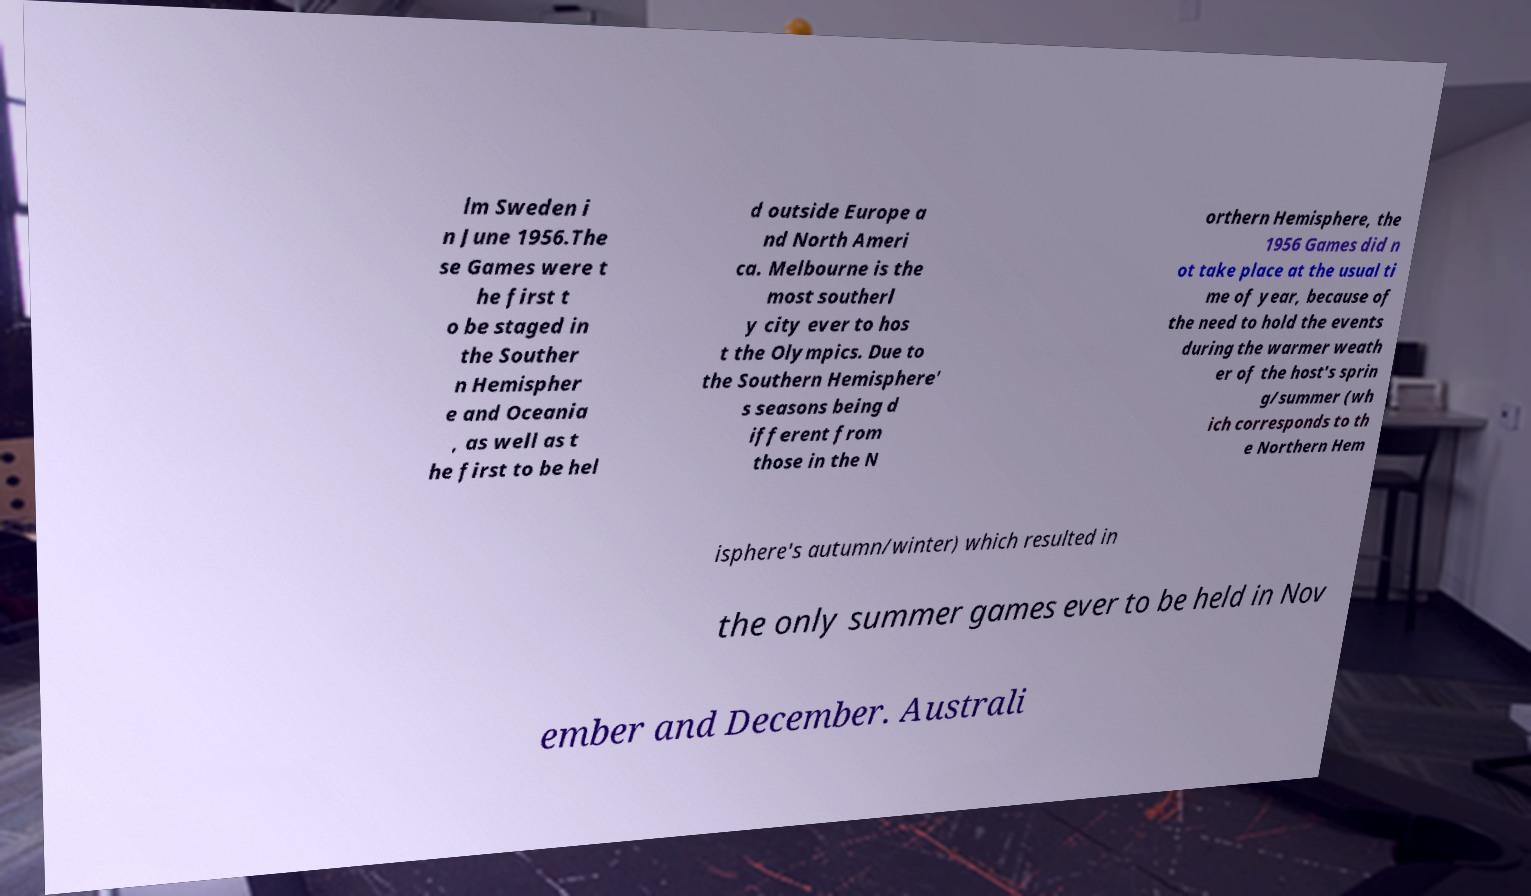There's text embedded in this image that I need extracted. Can you transcribe it verbatim? lm Sweden i n June 1956.The se Games were t he first t o be staged in the Souther n Hemispher e and Oceania , as well as t he first to be hel d outside Europe a nd North Ameri ca. Melbourne is the most southerl y city ever to hos t the Olympics. Due to the Southern Hemisphere' s seasons being d ifferent from those in the N orthern Hemisphere, the 1956 Games did n ot take place at the usual ti me of year, because of the need to hold the events during the warmer weath er of the host's sprin g/summer (wh ich corresponds to th e Northern Hem isphere's autumn/winter) which resulted in the only summer games ever to be held in Nov ember and December. Australi 